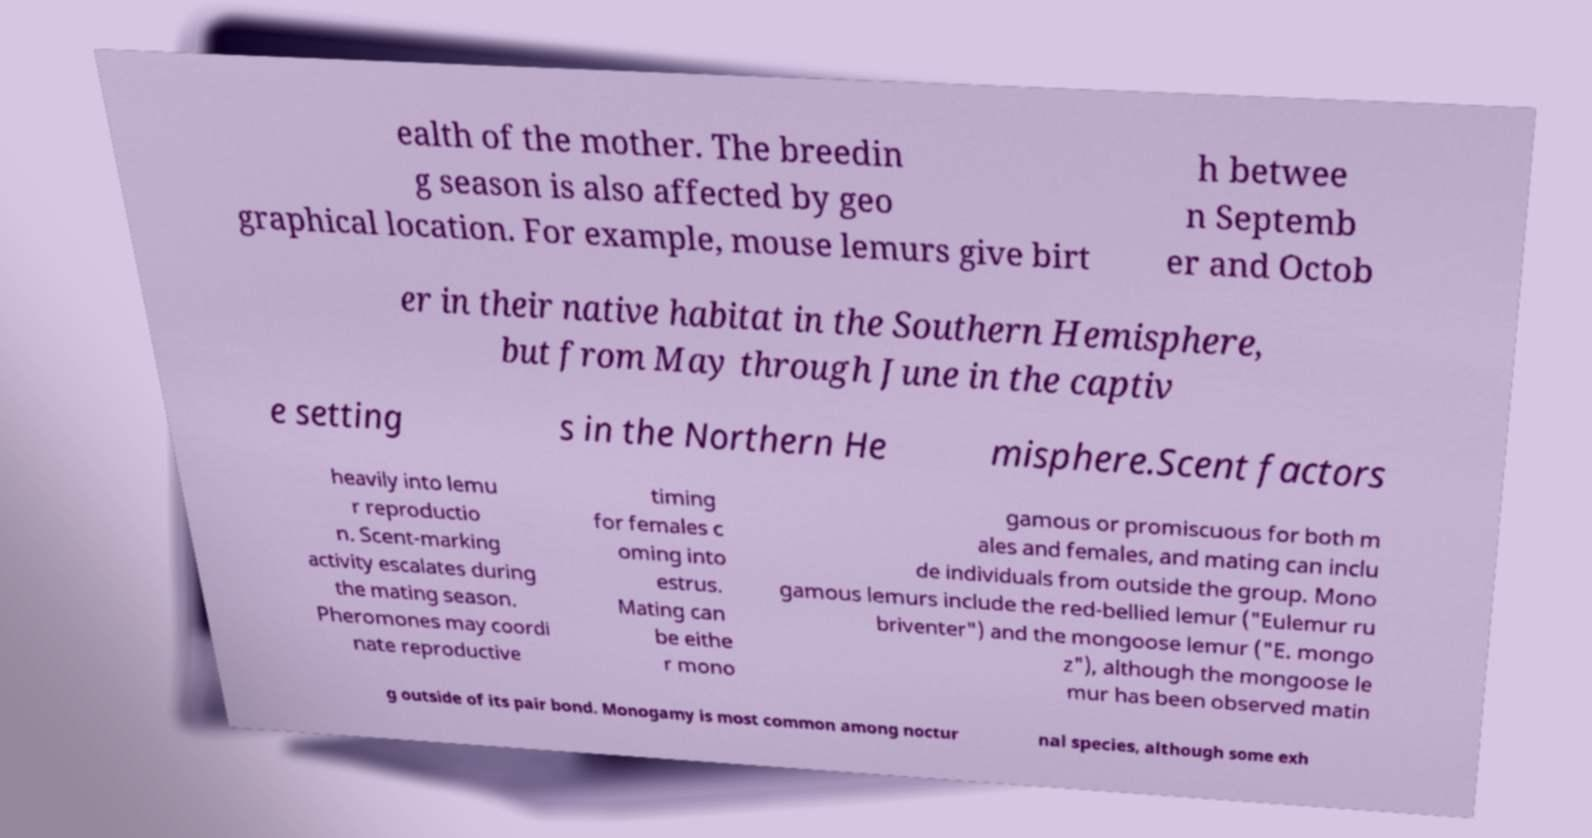There's text embedded in this image that I need extracted. Can you transcribe it verbatim? ealth of the mother. The breedin g season is also affected by geo graphical location. For example, mouse lemurs give birt h betwee n Septemb er and Octob er in their native habitat in the Southern Hemisphere, but from May through June in the captiv e setting s in the Northern He misphere.Scent factors heavily into lemu r reproductio n. Scent-marking activity escalates during the mating season. Pheromones may coordi nate reproductive timing for females c oming into estrus. Mating can be eithe r mono gamous or promiscuous for both m ales and females, and mating can inclu de individuals from outside the group. Mono gamous lemurs include the red-bellied lemur ("Eulemur ru briventer") and the mongoose lemur ("E. mongo z"), although the mongoose le mur has been observed matin g outside of its pair bond. Monogamy is most common among noctur nal species, although some exh 